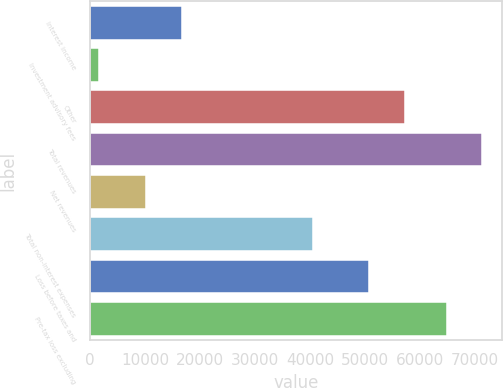Convert chart. <chart><loc_0><loc_0><loc_500><loc_500><bar_chart><fcel>Interest income<fcel>Investment advisory fees<fcel>Other<fcel>Total revenues<fcel>Net revenues<fcel>Total non-interest expenses<fcel>Loss before taxes and<fcel>Pre-tax loss excluding<nl><fcel>16730.3<fcel>1644<fcel>57281.3<fcel>71381.3<fcel>10198<fcel>40551<fcel>50749<fcel>64849<nl></chart> 